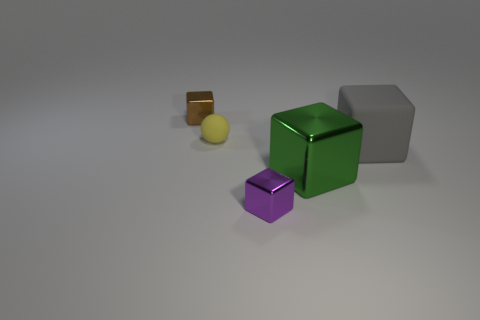Add 1 tiny green metal cylinders. How many objects exist? 6 Subtract all balls. How many objects are left? 4 Subtract all tiny yellow things. Subtract all tiny purple shiny cubes. How many objects are left? 3 Add 5 small objects. How many small objects are left? 8 Add 1 gray matte blocks. How many gray matte blocks exist? 2 Subtract 1 gray blocks. How many objects are left? 4 